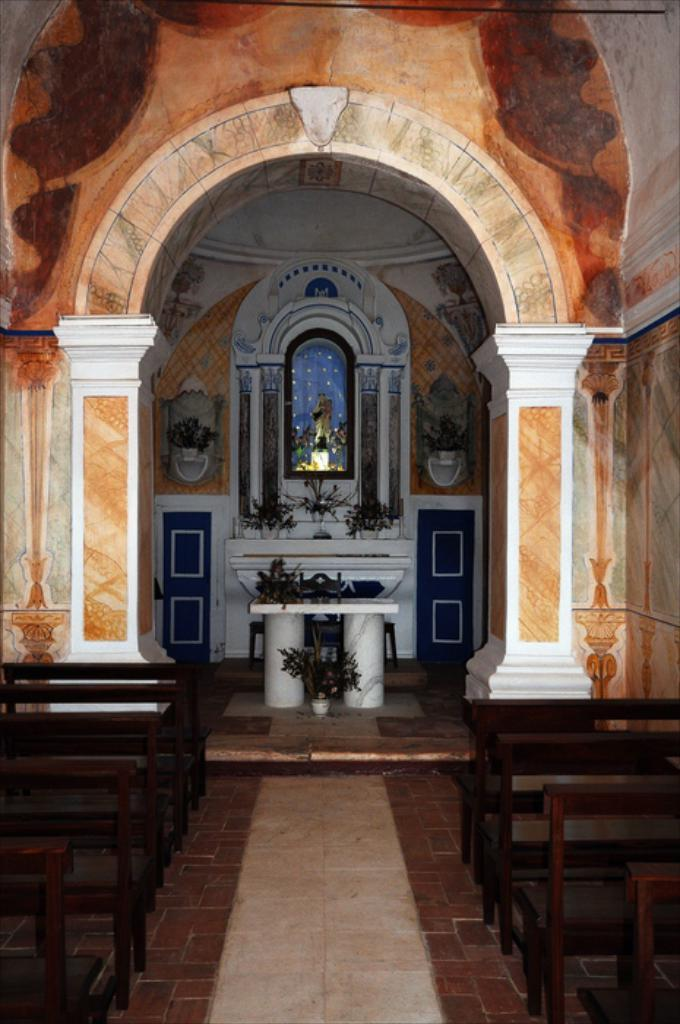What type of location is depicted in the image? The image is an inner view of a building. What type of furniture is present in the image? There are benches on the floor. What type of vegetation is present in the image? There are plants in pots. What type of structure is present in the image? There is a stand with poles. What type of artwork is present in the image? There is a statue beside a wall. What part of the building can be seen in the image? There is a roof visible in the image. What type of company does the statue represent in the image? There is no indication in the image that the statue represents a specific company. 